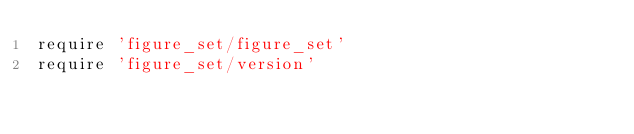Convert code to text. <code><loc_0><loc_0><loc_500><loc_500><_Ruby_>require 'figure_set/figure_set'
require 'figure_set/version'
</code> 